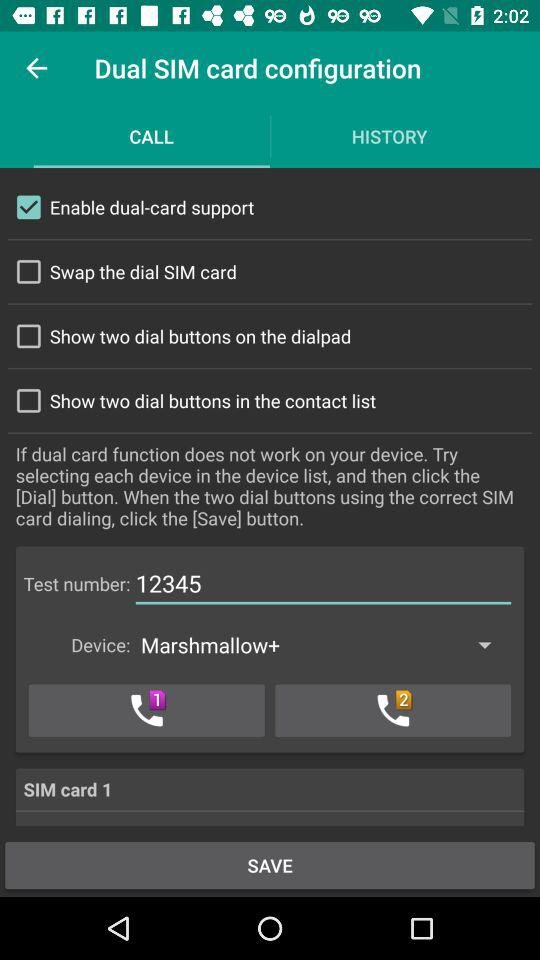What is the status of the "Swap the dial SIM card"? The status is "off". 